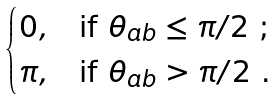<formula> <loc_0><loc_0><loc_500><loc_500>\begin{cases} 0 , & \text {if $\theta_{ab} \leq \pi/2$\ ;} \\ \pi , & \text {if $\theta_{ab} > \pi/2$\ .} \end{cases}</formula> 